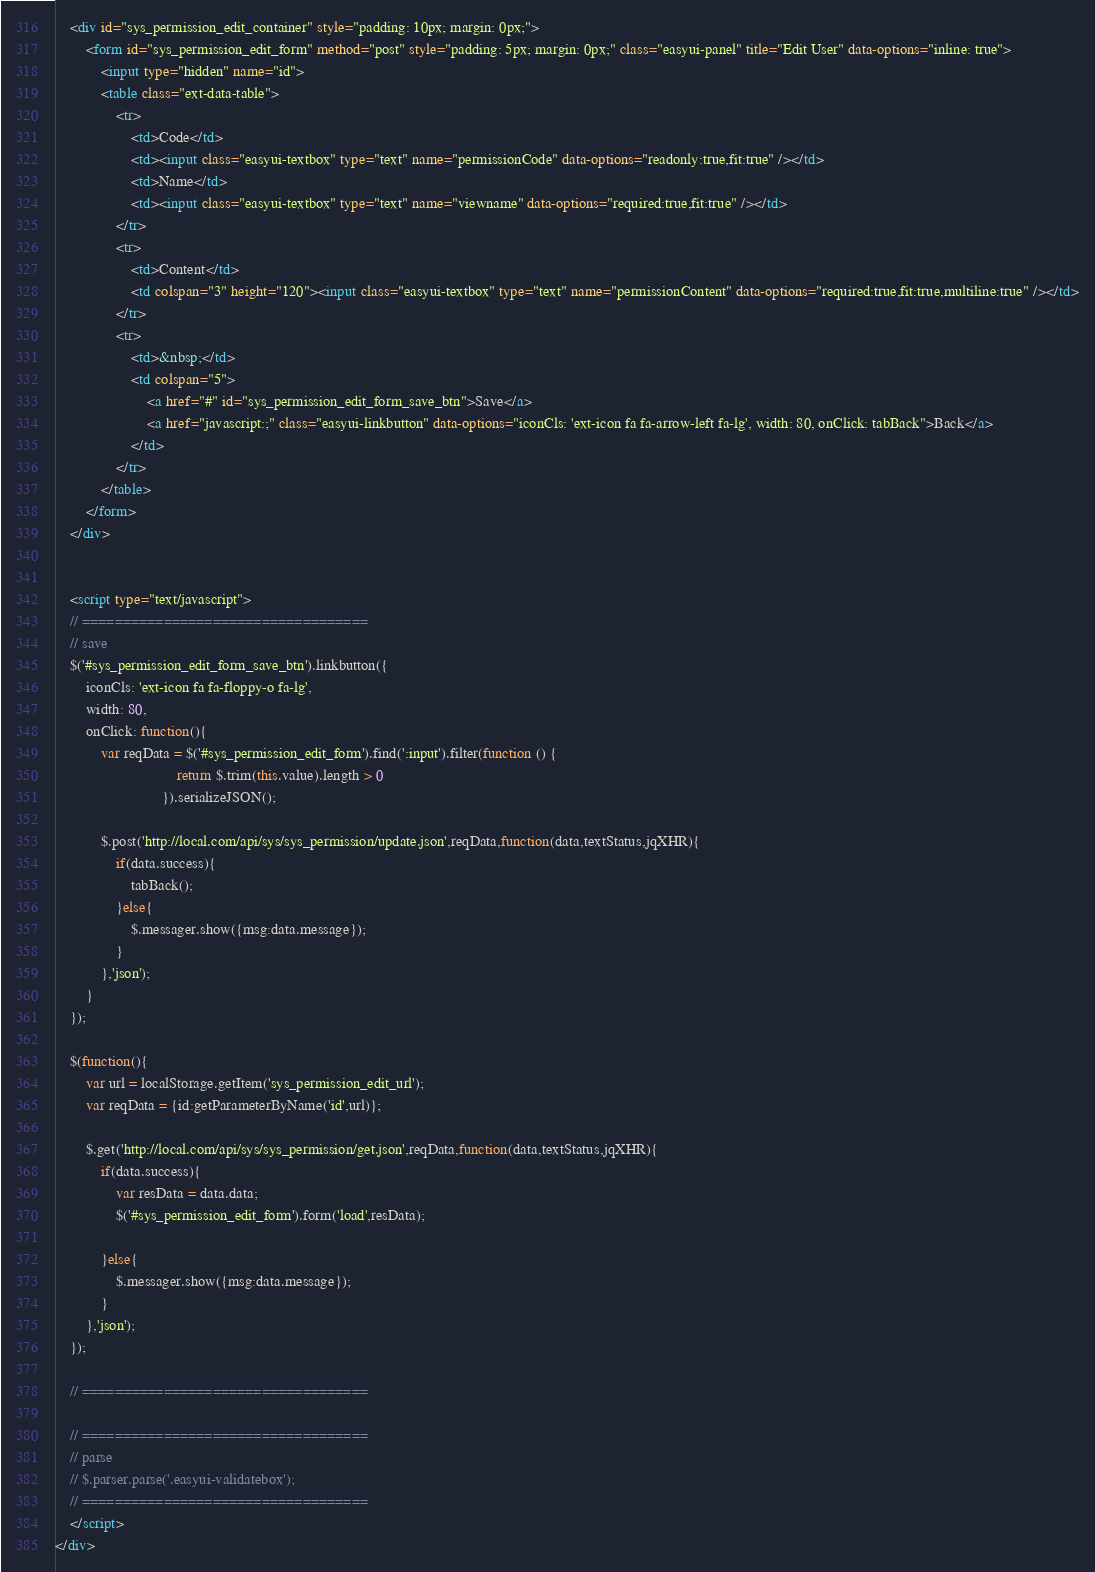Convert code to text. <code><loc_0><loc_0><loc_500><loc_500><_HTML_>
    <div id="sys_permission_edit_container" style="padding: 10px; margin: 0px;">
        <form id="sys_permission_edit_form" method="post" style="padding: 5px; margin: 0px;" class="easyui-panel" title="Edit User" data-options="inline: true">
            <input type="hidden" name="id">
            <table class="ext-data-table">
                <tr>
                    <td>Code</td>
                    <td><input class="easyui-textbox" type="text" name="permissionCode" data-options="readonly:true,fit:true" /></td>
                    <td>Name</td>
                    <td><input class="easyui-textbox" type="text" name="viewname" data-options="required:true,fit:true" /></td>
                </tr>
                <tr>
                    <td>Content</td>
                    <td colspan="3" height="120"><input class="easyui-textbox" type="text" name="permissionContent" data-options="required:true,fit:true,multiline:true" /></td>
                </tr>
                <tr>
                    <td>&nbsp;</td>
                    <td colspan="5">
                        <a href="#" id="sys_permission_edit_form_save_btn">Save</a>
                        <a href="javascript:;" class="easyui-linkbutton" data-options="iconCls: 'ext-icon fa fa-arrow-left fa-lg', width: 80, onClick: tabBack">Back</a>
                    </td>
                </tr>
            </table>
        </form>
    </div>


    <script type="text/javascript">
    // ===================================
    // save
    $('#sys_permission_edit_form_save_btn').linkbutton({
        iconCls: 'ext-icon fa fa-floppy-o fa-lg',
        width: 80,
        onClick: function(){
            var reqData = $('#sys_permission_edit_form').find(':input').filter(function () {
                                return $.trim(this.value).length > 0
                            }).serializeJSON();

            $.post('http://local.com/api/sys/sys_permission/update.json',reqData,function(data,textStatus,jqXHR){
                if(data.success){
                    tabBack();
                }else{
                    $.messager.show({msg:data.message});
                }
            },'json');
        }
    });

    $(function(){
        var url = localStorage.getItem('sys_permission_edit_url');
        var reqData = {id:getParameterByName('id',url)};

        $.get('http://local.com/api/sys/sys_permission/get.json',reqData,function(data,textStatus,jqXHR){
            if(data.success){
                var resData = data.data;
                $('#sys_permission_edit_form').form('load',resData);

            }else{
                $.messager.show({msg:data.message});
            }
        },'json');
    });

    // ===================================

    // ===================================
    // parse
    // $.parser.parse('.easyui-validatebox');
    // ===================================
    </script>
</div></code> 